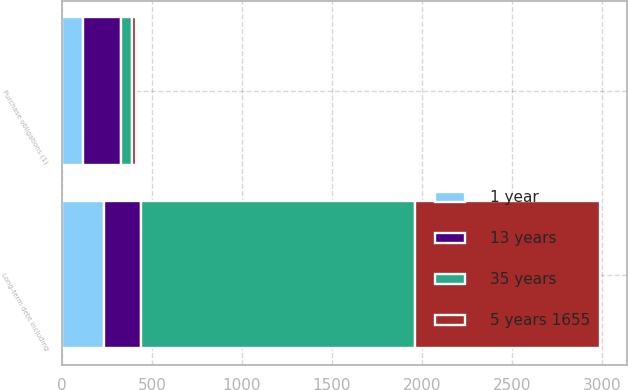<chart> <loc_0><loc_0><loc_500><loc_500><stacked_bar_chart><ecel><fcel>Long-term debt including<fcel>Purchase obligations (1)<nl><fcel>13 years<fcel>207<fcel>207<nl><fcel>1 year<fcel>231<fcel>118<nl><fcel>35 years<fcel>1523<fcel>66<nl><fcel>5 years 1655<fcel>1027<fcel>19<nl></chart> 